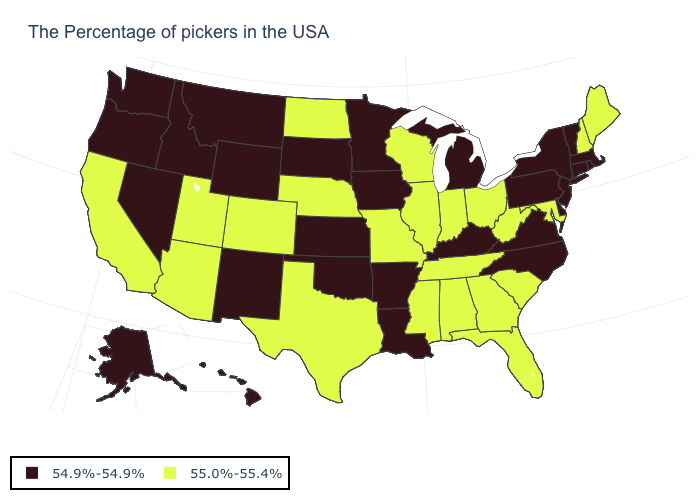Name the states that have a value in the range 54.9%-54.9%?
Write a very short answer. Massachusetts, Rhode Island, Vermont, Connecticut, New York, New Jersey, Delaware, Pennsylvania, Virginia, North Carolina, Michigan, Kentucky, Louisiana, Arkansas, Minnesota, Iowa, Kansas, Oklahoma, South Dakota, Wyoming, New Mexico, Montana, Idaho, Nevada, Washington, Oregon, Alaska, Hawaii. What is the value of Vermont?
Give a very brief answer. 54.9%-54.9%. Name the states that have a value in the range 54.9%-54.9%?
Write a very short answer. Massachusetts, Rhode Island, Vermont, Connecticut, New York, New Jersey, Delaware, Pennsylvania, Virginia, North Carolina, Michigan, Kentucky, Louisiana, Arkansas, Minnesota, Iowa, Kansas, Oklahoma, South Dakota, Wyoming, New Mexico, Montana, Idaho, Nevada, Washington, Oregon, Alaska, Hawaii. What is the lowest value in the USA?
Be succinct. 54.9%-54.9%. Does Nevada have a lower value than Kansas?
Keep it brief. No. Does the first symbol in the legend represent the smallest category?
Write a very short answer. Yes. What is the value of Connecticut?
Answer briefly. 54.9%-54.9%. Does Utah have the highest value in the West?
Give a very brief answer. Yes. What is the highest value in the USA?
Give a very brief answer. 55.0%-55.4%. Does Arizona have the lowest value in the USA?
Keep it brief. No. Does South Dakota have the lowest value in the MidWest?
Be succinct. Yes. Name the states that have a value in the range 54.9%-54.9%?
Write a very short answer. Massachusetts, Rhode Island, Vermont, Connecticut, New York, New Jersey, Delaware, Pennsylvania, Virginia, North Carolina, Michigan, Kentucky, Louisiana, Arkansas, Minnesota, Iowa, Kansas, Oklahoma, South Dakota, Wyoming, New Mexico, Montana, Idaho, Nevada, Washington, Oregon, Alaska, Hawaii. Among the states that border Vermont , does New York have the highest value?
Quick response, please. No. Name the states that have a value in the range 55.0%-55.4%?
Give a very brief answer. Maine, New Hampshire, Maryland, South Carolina, West Virginia, Ohio, Florida, Georgia, Indiana, Alabama, Tennessee, Wisconsin, Illinois, Mississippi, Missouri, Nebraska, Texas, North Dakota, Colorado, Utah, Arizona, California. 